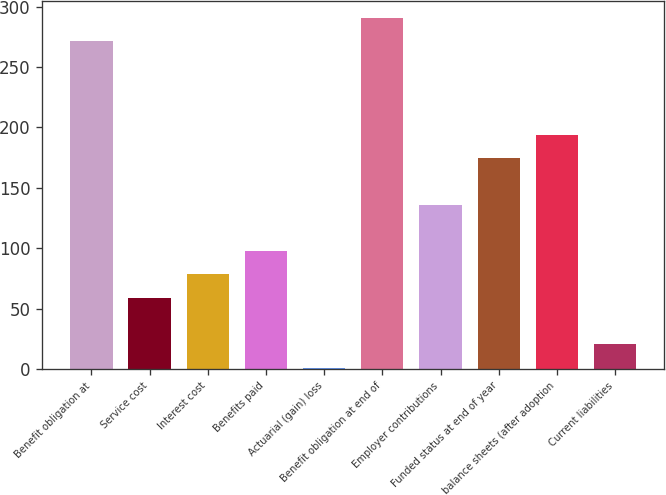Convert chart to OTSL. <chart><loc_0><loc_0><loc_500><loc_500><bar_chart><fcel>Benefit obligation at<fcel>Service cost<fcel>Interest cost<fcel>Benefits paid<fcel>Actuarial (gain) loss<fcel>Benefit obligation at end of<fcel>Employer contributions<fcel>Funded status at end of year<fcel>balance sheets (after adoption<fcel>Current liabilities<nl><fcel>271.2<fcel>58.9<fcel>78.2<fcel>97.5<fcel>1<fcel>290.5<fcel>136.1<fcel>174.7<fcel>194<fcel>20.3<nl></chart> 